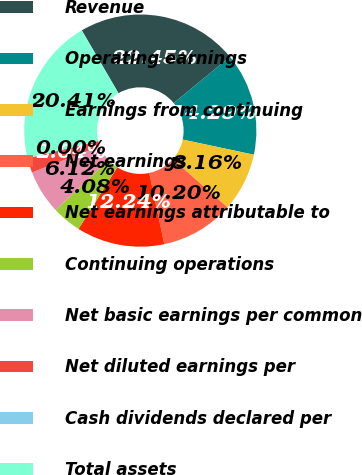<chart> <loc_0><loc_0><loc_500><loc_500><pie_chart><fcel>Revenue<fcel>Operating earnings<fcel>Earnings from continuing<fcel>Net earnings<fcel>Net earnings attributable to<fcel>Continuing operations<fcel>Net basic earnings per common<fcel>Net diluted earnings per<fcel>Cash dividends declared per<fcel>Total assets<nl><fcel>22.45%<fcel>14.29%<fcel>8.16%<fcel>10.2%<fcel>12.24%<fcel>4.08%<fcel>6.12%<fcel>2.04%<fcel>0.0%<fcel>20.41%<nl></chart> 